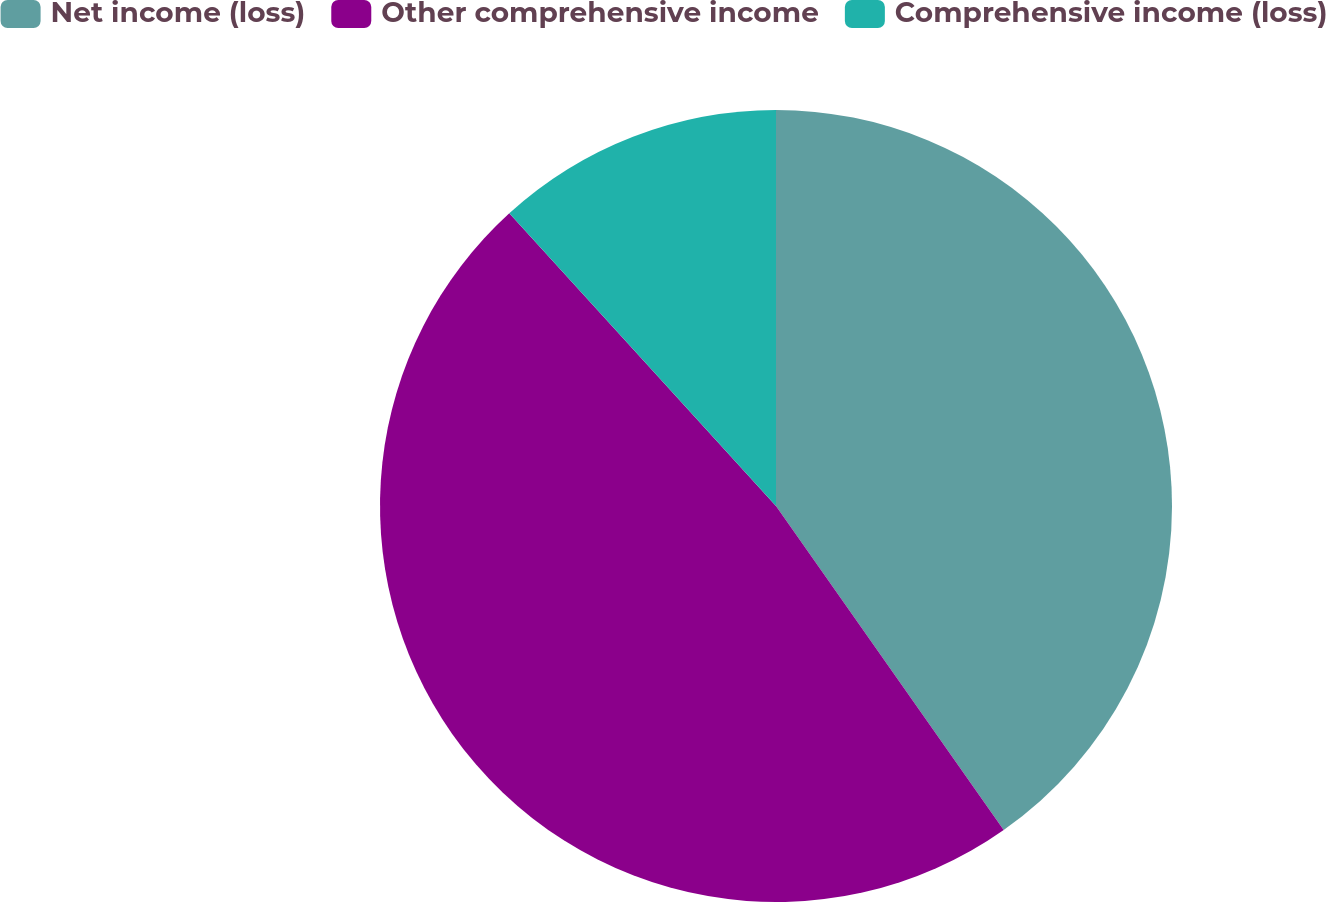Convert chart. <chart><loc_0><loc_0><loc_500><loc_500><pie_chart><fcel>Net income (loss)<fcel>Other comprehensive income<fcel>Comprehensive income (loss)<nl><fcel>40.25%<fcel>47.99%<fcel>11.76%<nl></chart> 